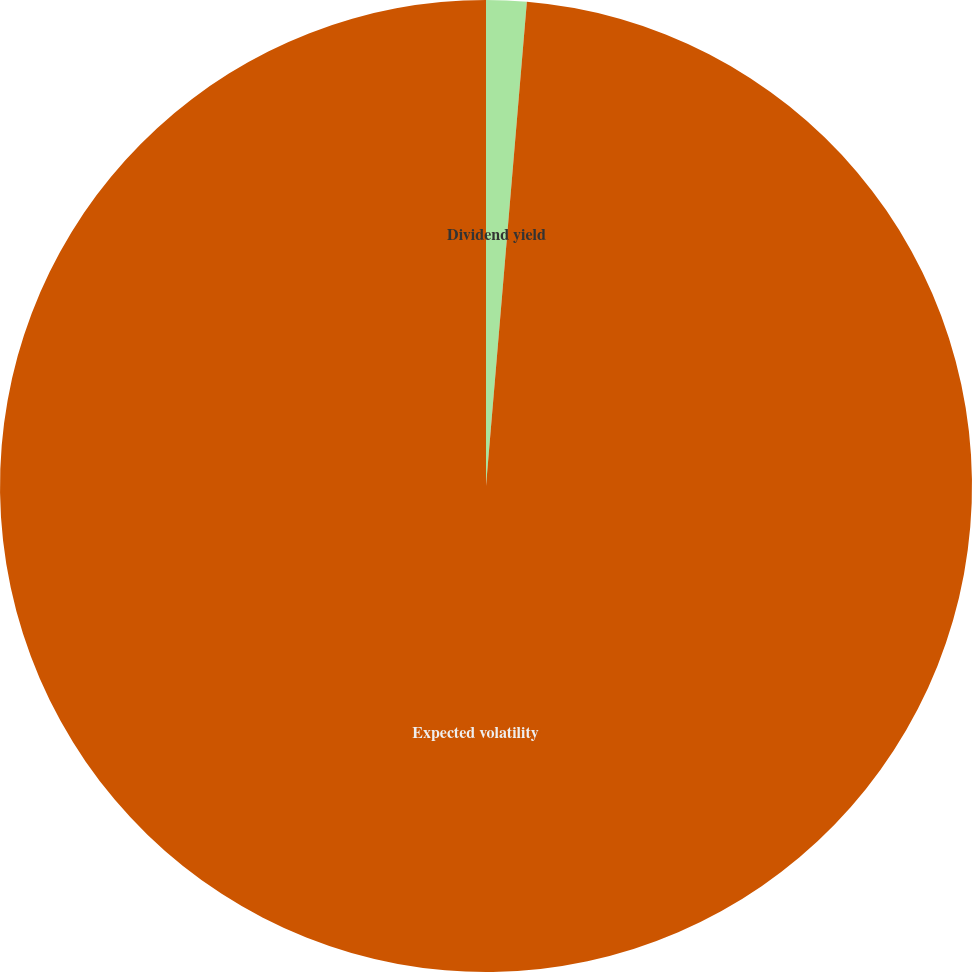Convert chart to OTSL. <chart><loc_0><loc_0><loc_500><loc_500><pie_chart><fcel>Dividend yield<fcel>Expected volatility<nl><fcel>1.34%<fcel>98.66%<nl></chart> 